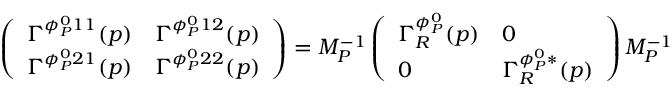<formula> <loc_0><loc_0><loc_500><loc_500>\left ( \begin{array} { l l } { { \Gamma ^ { \phi _ { P } ^ { 0 } 1 1 } ( p ) } } & { { \Gamma ^ { \phi _ { P } ^ { 0 } 1 2 } ( p ) } } \\ { { \Gamma ^ { \phi _ { P } ^ { 0 } 2 1 } ( p ) } } & { { \Gamma ^ { \phi _ { P } ^ { 0 } 2 2 } ( p ) } } \end{array} \right ) = M _ { P } ^ { - 1 } \left ( \begin{array} { l l } { { \Gamma _ { R } ^ { \phi _ { P } ^ { 0 } } ( p ) } } & { 0 } \\ { 0 } & { { \Gamma _ { R } ^ { \phi _ { P } ^ { 0 } * } ( p ) } } \end{array} \right ) M _ { P } ^ { - 1 }</formula> 